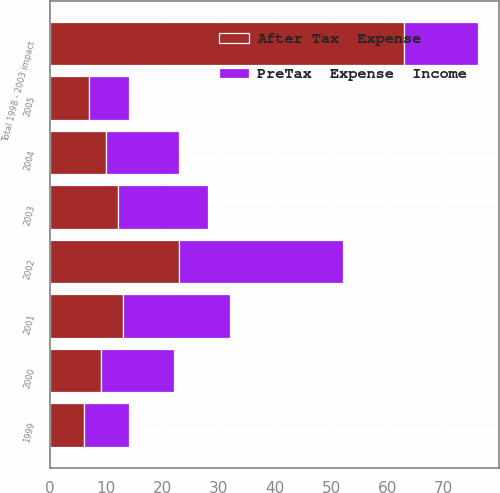<chart> <loc_0><loc_0><loc_500><loc_500><stacked_bar_chart><ecel><fcel>1999<fcel>2000<fcel>2001<fcel>2002<fcel>2003<fcel>Total 1998 - 2003 impact<fcel>2004<fcel>2005<nl><fcel>PreTax  Expense  Income<fcel>8<fcel>13<fcel>19<fcel>29<fcel>16<fcel>13<fcel>13<fcel>7<nl><fcel>After Tax  Expense<fcel>6<fcel>9<fcel>13<fcel>23<fcel>12<fcel>63<fcel>10<fcel>7<nl></chart> 